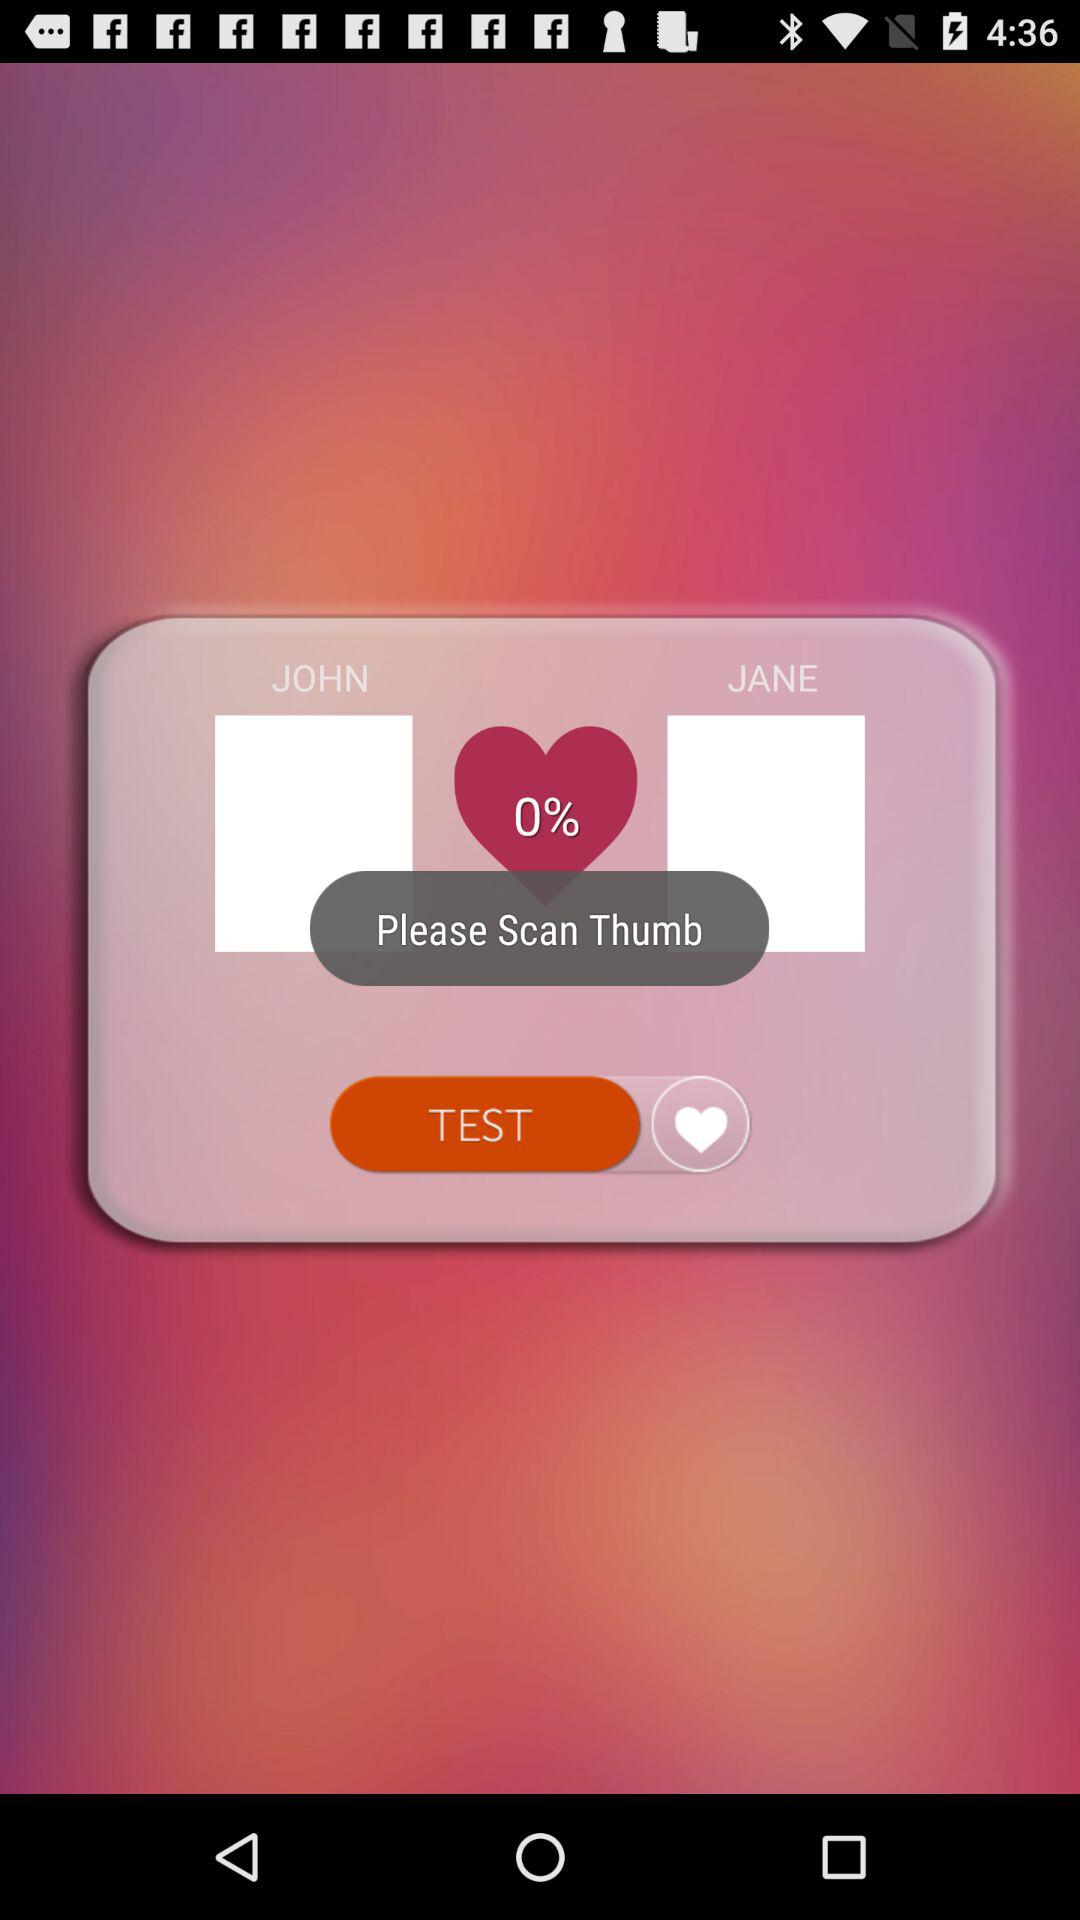What is the match percentage? The match percentage is 0. 